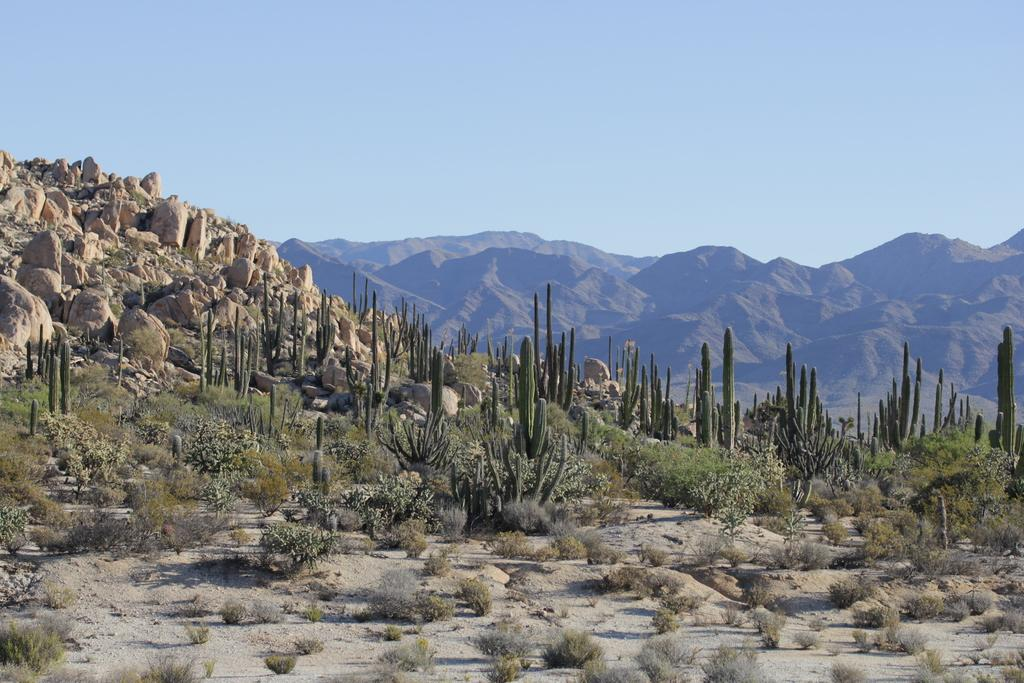What is located in the middle of the image? There are plants in the middle of the image. What can be seen on the left side of the image? There are stones on the left side of the image. What type of natural formation is visible in the background of the image? There are hills visible in the background of the image. What is visible at the top of the image? The sky is visible at the top of the image. Can you tell me how many giraffes are depicted in the image? There are no giraffes present in the image; it features plants, stones, hills, and the sky. What invention is being used by the plants in the image? There is no invention present in the image; the plants are natural vegetation. 